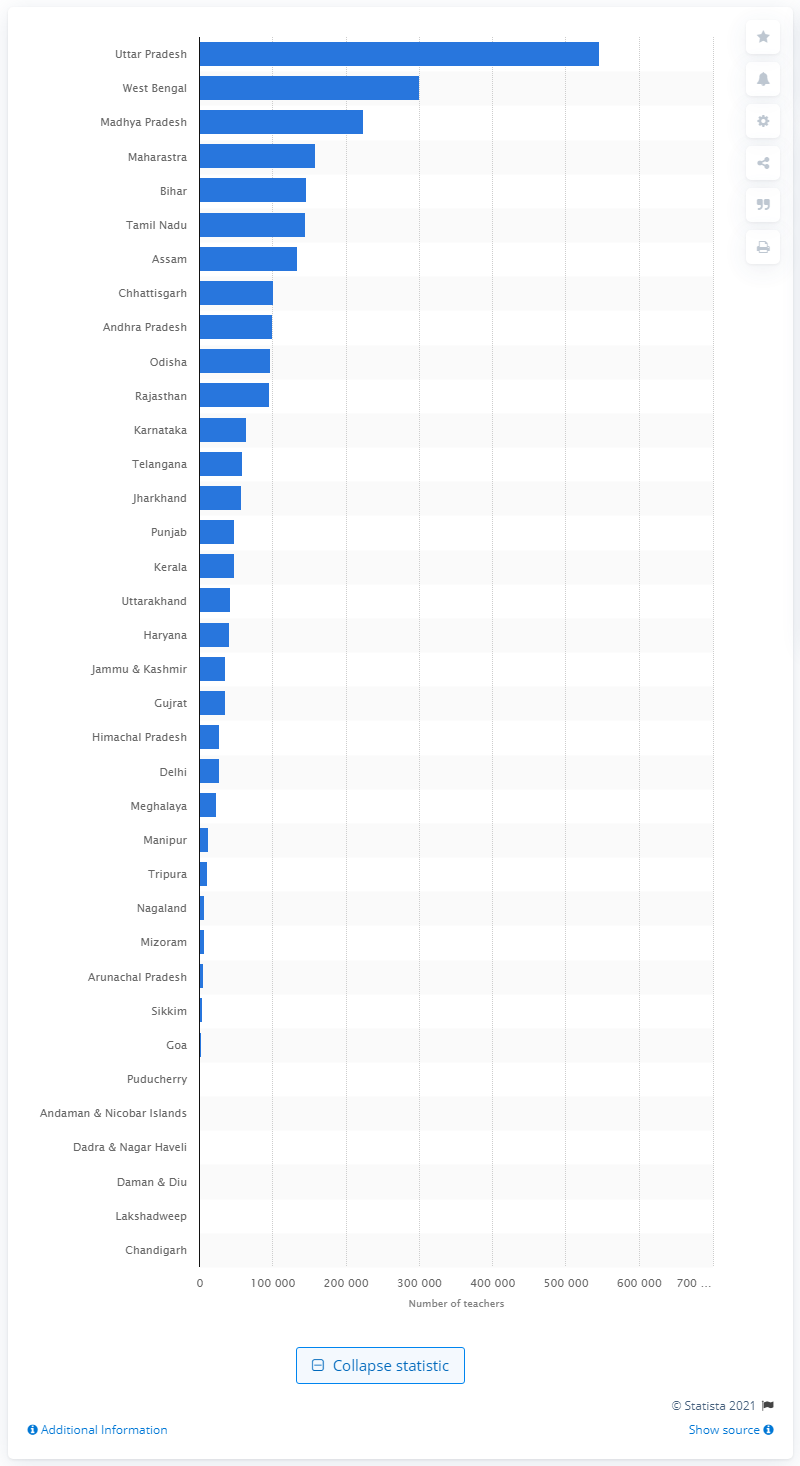Identify some key points in this picture. The union territory of Chandigarh had the lowest number of primary school teachers in 2014 among all union territories. Uttar Pradesh had the highest number of primary school teachers in 2014. 